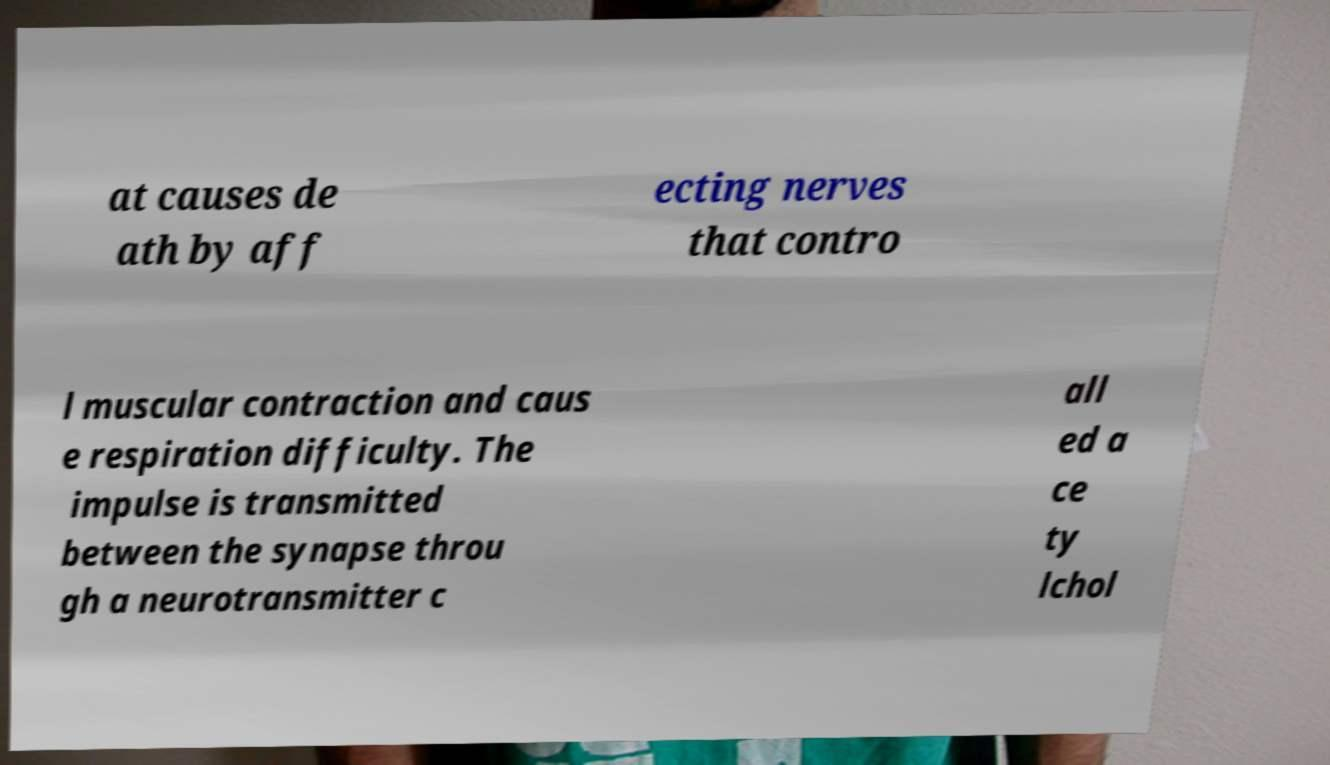I need the written content from this picture converted into text. Can you do that? at causes de ath by aff ecting nerves that contro l muscular contraction and caus e respiration difficulty. The impulse is transmitted between the synapse throu gh a neurotransmitter c all ed a ce ty lchol 